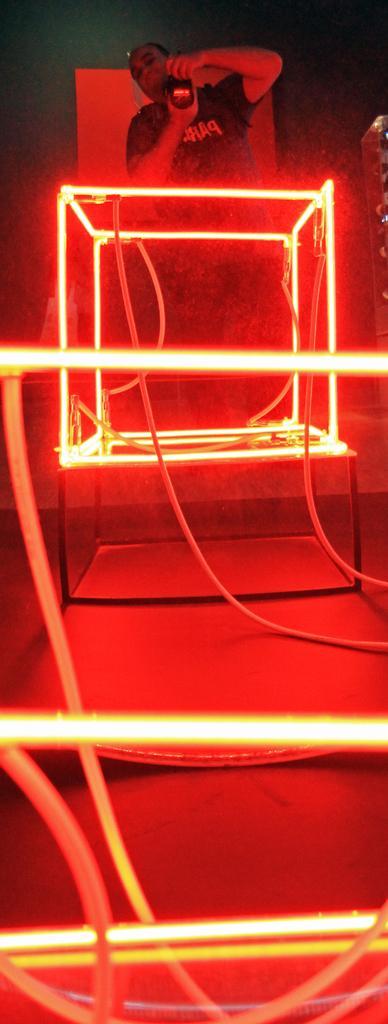Please provide a concise description of this image. In this image there is a person holding a camera in his hand. He is standing behind the box having lights. 